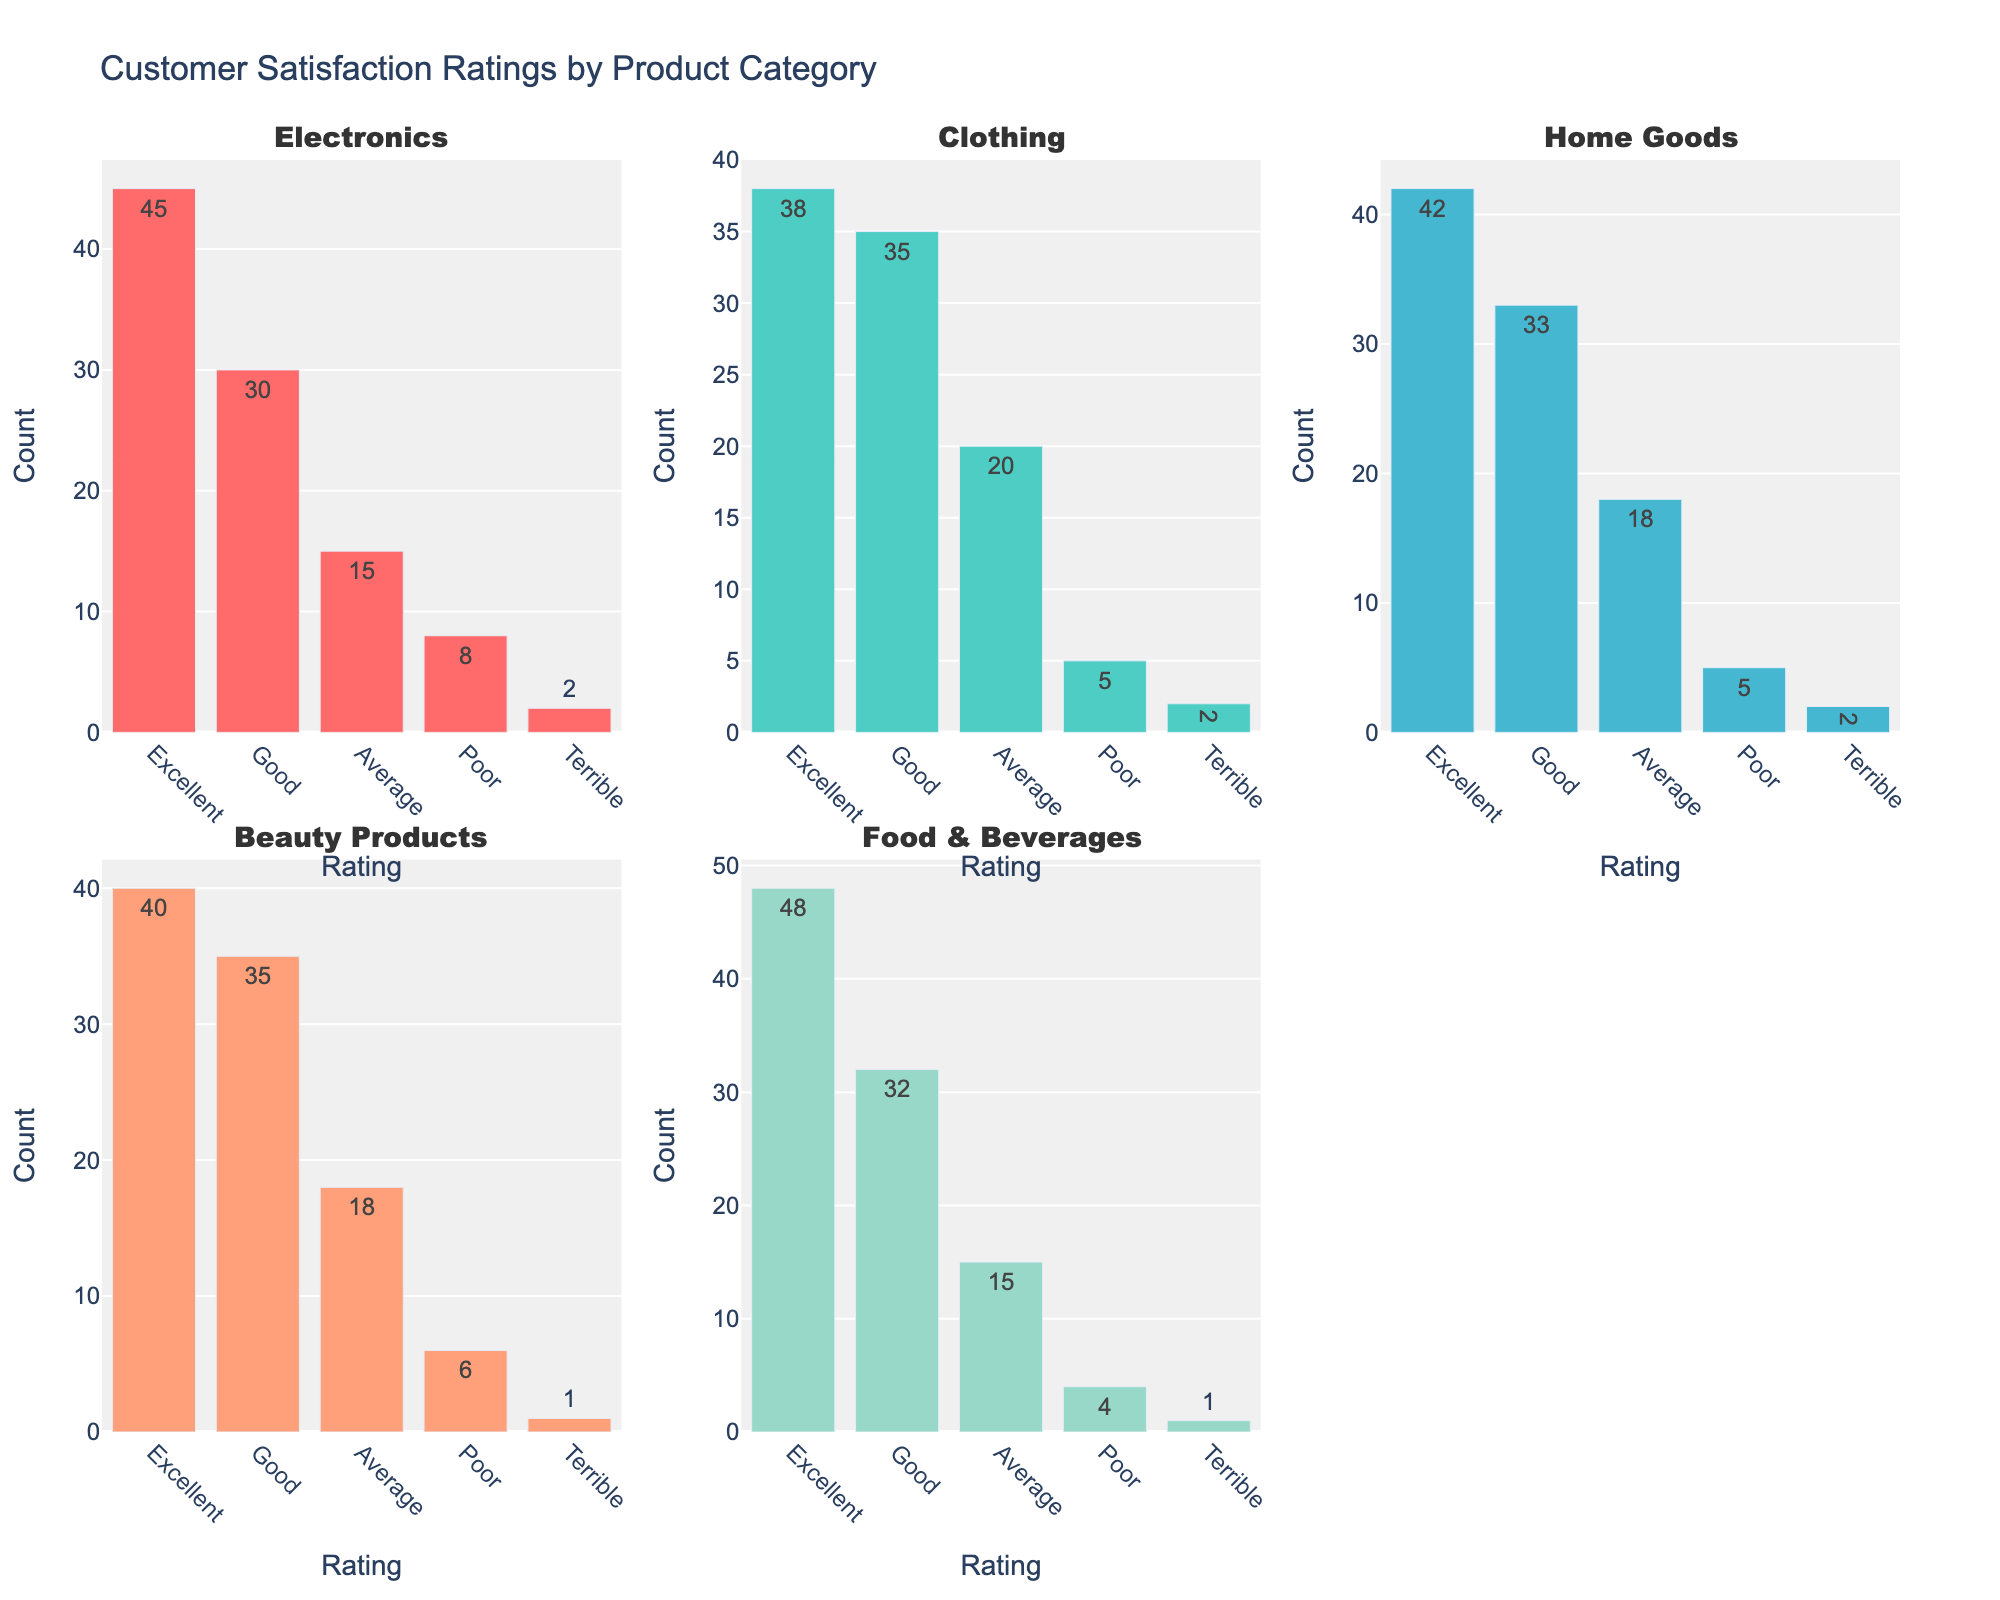What is the title of the grid of subplots? The title is displayed at the top of the figure and indicates the overall topic of the visualization.
Answer: Memory-Enhancing Techniques for Seniors How many subplots are there in the figure? The figure is divided into a grid with rows and columns, and each section contains a subplot.
Answer: 4 What color represents the 65-75 age group in the subplots? The color is used consistently across all subplots to identify the same age group.
Answer: Light Salmon Which technique has the highest effectiveness in the 75-85 age group? By looking at the bar heights in the "Comparison by Age Group" subplot and focusing on the 75-85 group color, you can identify the technique with the highest bar.
Answer: Social Engagement How does the ease of use for Memory Games compare between the two age groups? Examine the “Ease of Use vs Weekly Practice” subplot for both age groups and locate the data points labeled "Memory Games."
Answer: Memory Games is rated 7 for 65-75 and 6 for 75-85 Which subplot would you check to see the relationship between weekly practice and effectiveness? Identify the subplot by looking at its axis labels where one axis represents weekly practice and the other represents effectiveness.
Answer: Effectiveness vs Weekly Practice For the technique "Physical Exercise," which age group practices it more weekly? Locate the data points for "Physical Exercise" in the "Ease of Use vs Weekly Practice" subplot and compare their positions on the weekly practice axis for both age groups.
Answer: 65-75 age group Which technique has the lowest ease of use in the 75-85 age group? In the “Ease of Use vs Weekly Practice” subplot, find the lowest ease of use rating among the techniques labeled for the 75-85 age group.
Answer: Physical Exercise Does Social Engagement require more or less weekly practice than Meditation in the 65-75 age group? Compare the positions of the data points for Social Engagement and Meditation on the weekly practice axis in the "Effectiveness vs Weekly Practice" subplot for the 65-75 age group.
Answer: More What is the effectiveness percentage of Healthy Diet for the 65-75 age group? The effectiveness percentage is shown next to the “Healthy Diet” data point specifically for the 65-75 age group.
Answer: 60% 